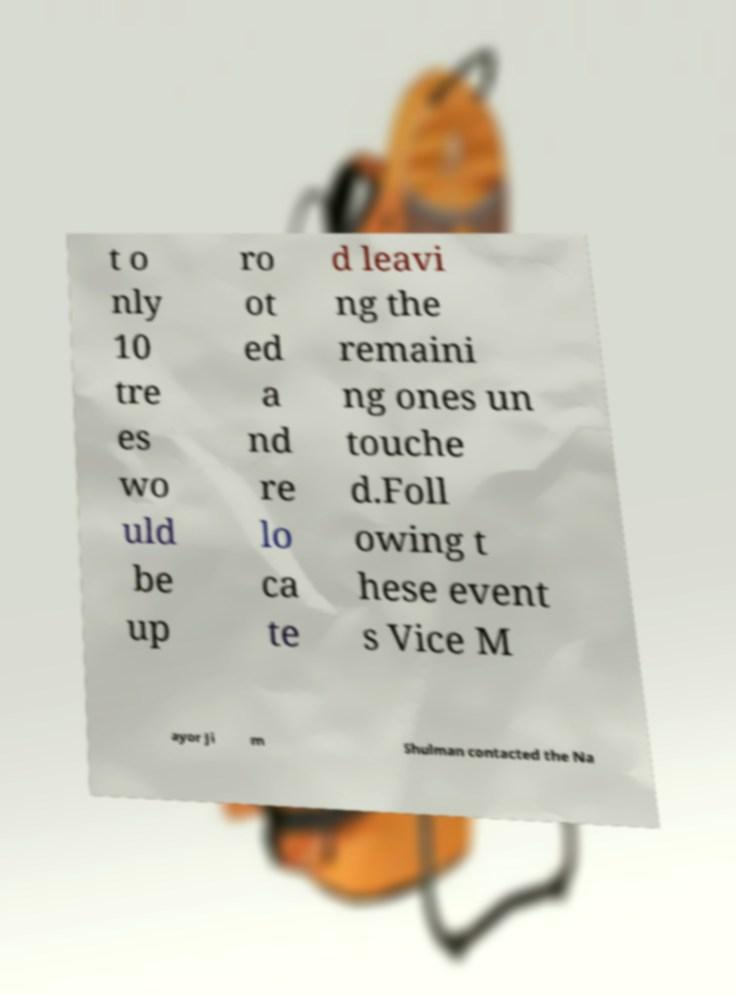Could you assist in decoding the text presented in this image and type it out clearly? t o nly 10 tre es wo uld be up ro ot ed a nd re lo ca te d leavi ng the remaini ng ones un touche d.Foll owing t hese event s Vice M ayor Ji m Shulman contacted the Na 